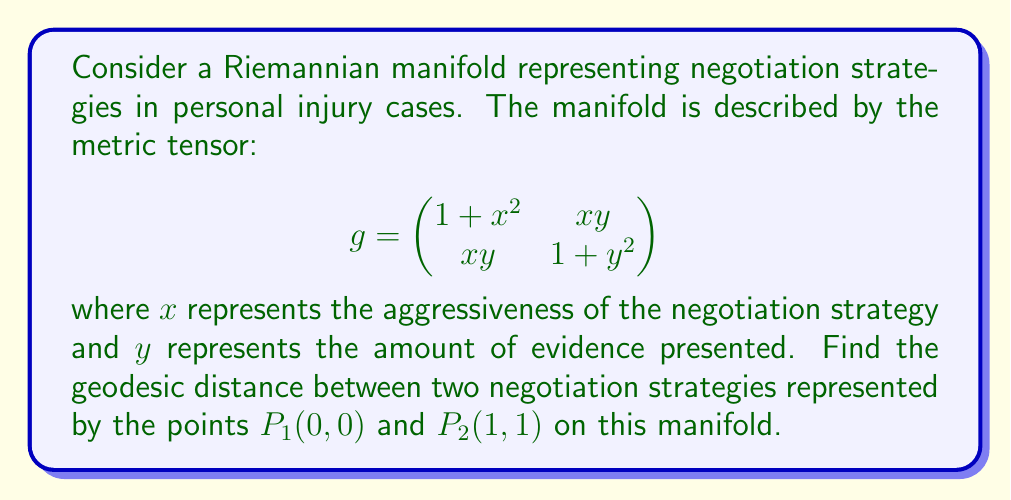Help me with this question. To find the geodesic distance between two points on a Riemannian manifold, we need to solve the geodesic equation and then calculate the length of the geodesic curve. However, for this specific problem, we can use a simpler approach:

1) First, we need to calculate the Christoffel symbols. For a 2D manifold, there are 8 unique Christoffel symbols:

   $$\Gamma^1_{11} = \frac{x}{1+x^2}, \Gamma^1_{12} = \Gamma^1_{21} = -\frac{y}{1+x^2}, \Gamma^1_{22} = \frac{x}{1+x^2}$$
   $$\Gamma^2_{11} = -\frac{x}{1+y^2}, \Gamma^2_{12} = \Gamma^2_{21} = \frac{y}{1+y^2}, \Gamma^2_{22} = \frac{y}{1+y^2}$$

2) The geodesic equation is:

   $$\frac{d^2x^i}{dt^2} + \Gamma^i_{jk}\frac{dx^j}{dt}\frac{dx^k}{dt} = 0$$

3) For this manifold, the geodesic equations are:

   $$\frac{d^2x}{dt^2} + \frac{x}{1+x^2}\left(\frac{dx}{dt}\right)^2 - \frac{2y}{1+x^2}\frac{dx}{dt}\frac{dy}{dt} + \frac{x}{1+x^2}\left(\frac{dy}{dt}\right)^2 = 0$$
   $$\frac{d^2y}{dt^2} - \frac{x}{1+y^2}\left(\frac{dx}{dt}\right)^2 + \frac{2y}{1+y^2}\frac{dx}{dt}\frac{dy}{dt} + \frac{y}{1+y^2}\left(\frac{dy}{dt}\right)^2 = 0$$

4) These equations are difficult to solve analytically. However, we can observe that the straight line $y=x$ connects our two points and satisfies the geodesic equations. This is because the metric is symmetric in $x$ and $y$.

5) Therefore, we can parametrize our geodesic as $x(t) = y(t) = t$, where $0 \leq t \leq 1$.

6) The geodesic distance is then given by:

   $$d = \int_0^1 \sqrt{g_{ij}\frac{dx^i}{dt}\frac{dx^j}{dt}}dt = \int_0^1 \sqrt{(1+t^2) + 2t^2 + (1+t^2)}dt = \int_0^1 \sqrt{2+4t^2}dt$$

7) This integral can be solved using the substitution $u = 2t$:

   $$d = \frac{1}{\sqrt{2}}\int_0^{\sqrt{2}} \sqrt{1+u^2}du = \frac{1}{\sqrt{2}}\left[\frac{u}{2}\sqrt{1+u^2} + \frac{1}{2}\ln(u+\sqrt{1+u^2})\right]_0^{\sqrt{2}}$$

8) Evaluating this:

   $$d = \frac{1}{\sqrt{2}}\left[\frac{\sqrt{2}}{2}\sqrt{3} + \frac{1}{2}\ln(\sqrt{2}+\sqrt{3}) - 0\right] = \frac{\sqrt{3}}{2} + \frac{1}{2\sqrt{2}}\ln(\sqrt{2}+\sqrt{3})$$
Answer: The geodesic distance between $P_1(0,0)$ and $P_2(1,1)$ is $\frac{\sqrt{3}}{2} + \frac{1}{2\sqrt{2}}\ln(\sqrt{2}+\sqrt{3})$. 